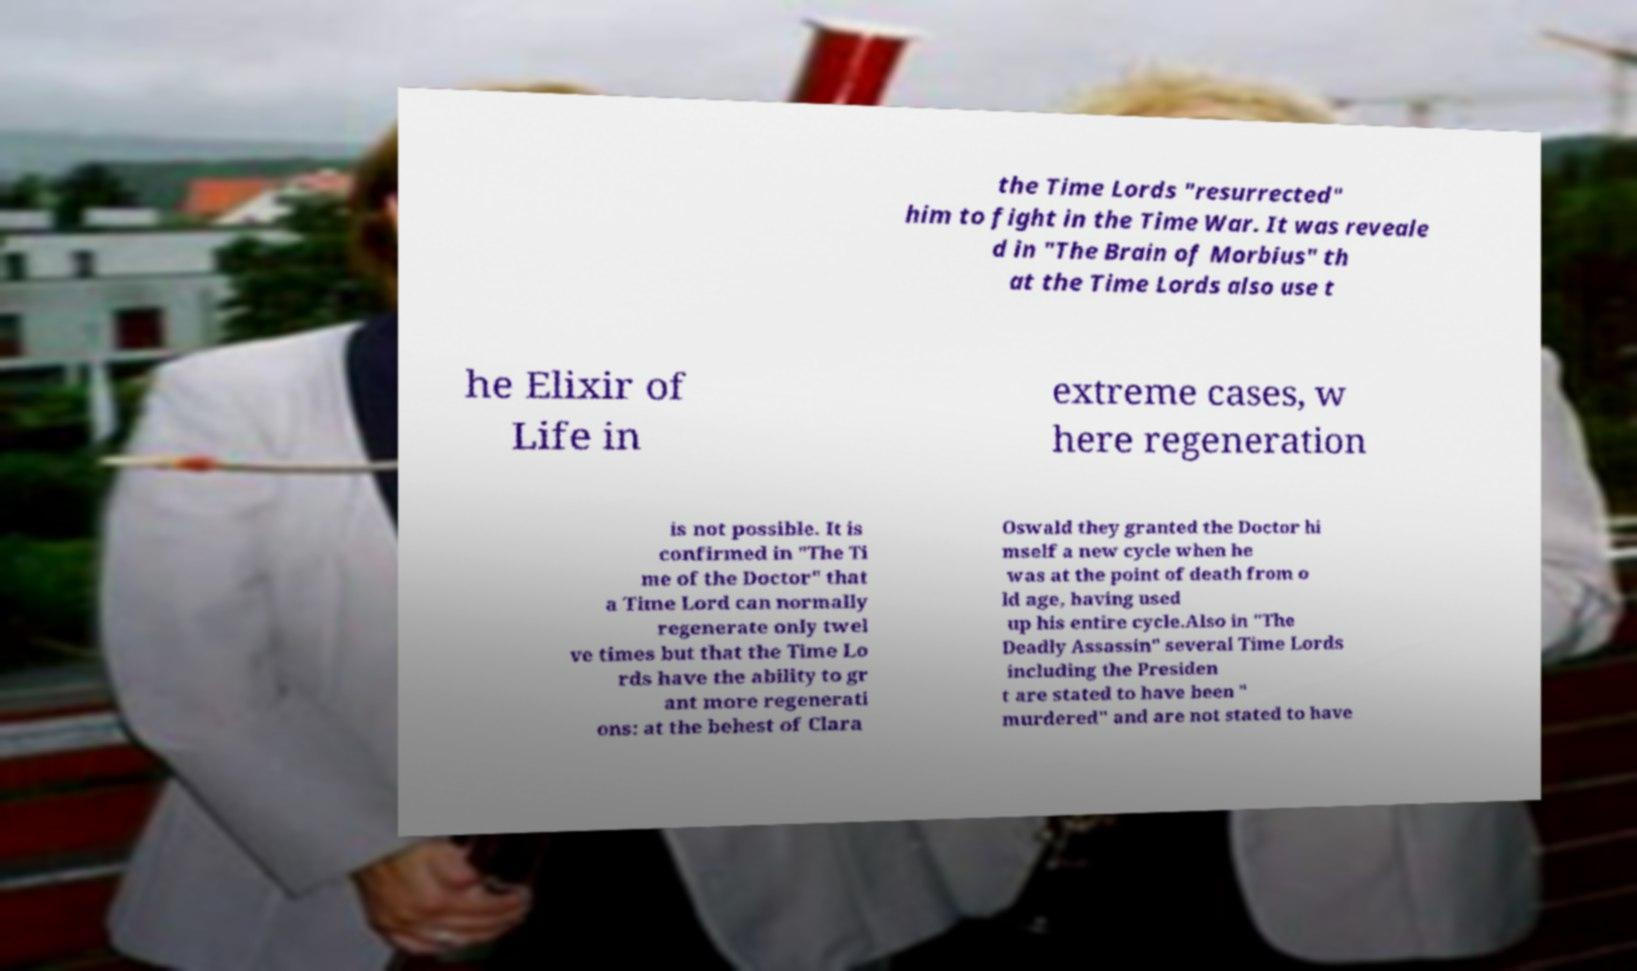Can you read and provide the text displayed in the image?This photo seems to have some interesting text. Can you extract and type it out for me? the Time Lords "resurrected" him to fight in the Time War. It was reveale d in "The Brain of Morbius" th at the Time Lords also use t he Elixir of Life in extreme cases, w here regeneration is not possible. It is confirmed in "The Ti me of the Doctor" that a Time Lord can normally regenerate only twel ve times but that the Time Lo rds have the ability to gr ant more regenerati ons: at the behest of Clara Oswald they granted the Doctor hi mself a new cycle when he was at the point of death from o ld age, having used up his entire cycle.Also in "The Deadly Assassin" several Time Lords including the Presiden t are stated to have been " murdered" and are not stated to have 